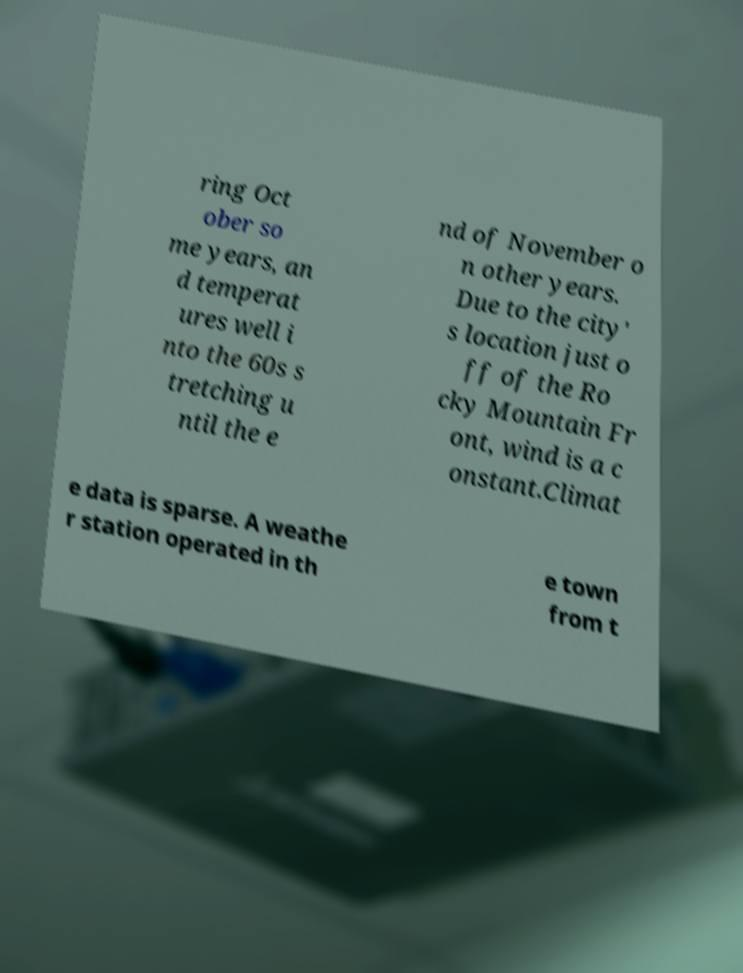Can you accurately transcribe the text from the provided image for me? ring Oct ober so me years, an d temperat ures well i nto the 60s s tretching u ntil the e nd of November o n other years. Due to the city' s location just o ff of the Ro cky Mountain Fr ont, wind is a c onstant.Climat e data is sparse. A weathe r station operated in th e town from t 